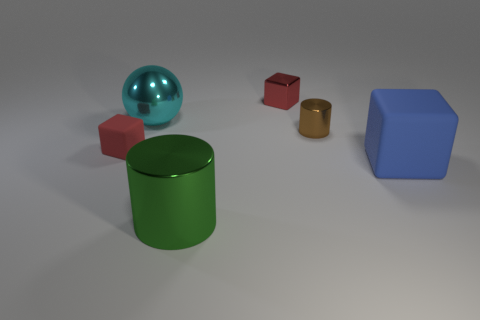There is another small cube that is the same color as the metal cube; what is its material?
Give a very brief answer. Rubber. Does the rubber object that is behind the large blue rubber object have the same shape as the large object that is to the right of the large green cylinder?
Your answer should be very brief. Yes. What number of other things are there of the same color as the small cylinder?
Your response must be concise. 0. What is the material of the block in front of the small red thing that is to the left of the small shiny cube that is behind the large rubber object?
Provide a succinct answer. Rubber. The large thing behind the large blue object that is to the right of the big green object is made of what material?
Offer a very short reply. Metal. Is the number of metallic things that are on the right side of the big blue thing less than the number of brown rubber cubes?
Your response must be concise. No. There is a blue thing on the right side of the red rubber object; what shape is it?
Give a very brief answer. Cube. Does the cyan sphere have the same size as the cylinder behind the tiny red matte object?
Offer a very short reply. No. Are there any small blocks that have the same material as the large blue thing?
Offer a terse response. Yes. How many spheres are either small red metal things or tiny matte things?
Offer a very short reply. 0. 